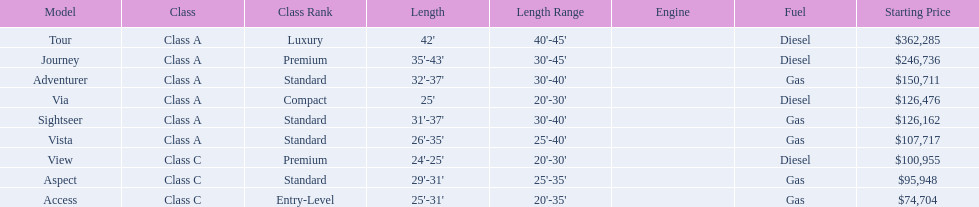What are all of the winnebago models? Tour, Journey, Adventurer, Via, Sightseer, Vista, View, Aspect, Access. What are their prices? $362,285, $246,736, $150,711, $126,476, $126,162, $107,717, $100,955, $95,948, $74,704. And which model costs the most? Tour. 